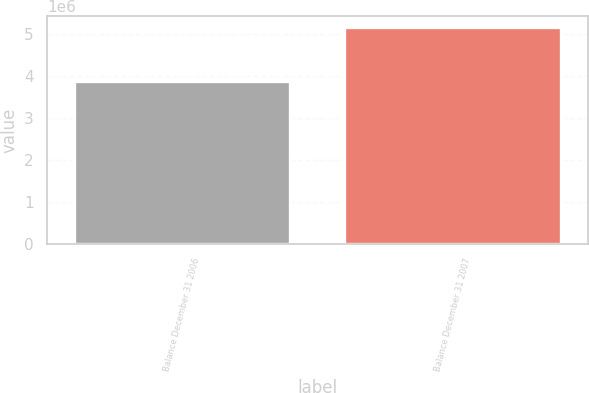<chart> <loc_0><loc_0><loc_500><loc_500><bar_chart><fcel>Balance December 31 2006<fcel>Balance December 31 2007<nl><fcel>3.87704e+06<fcel>5.17227e+06<nl></chart> 